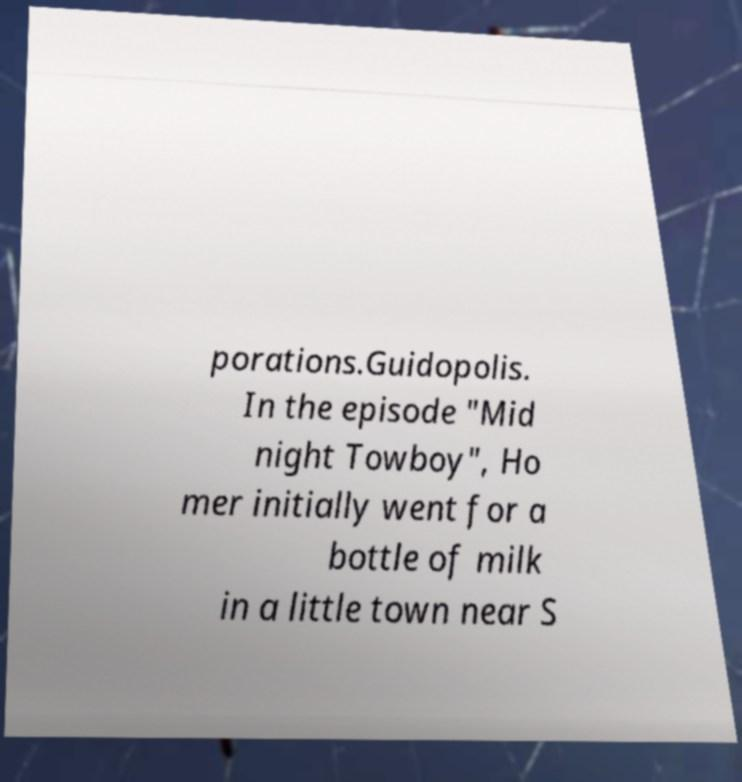Could you assist in decoding the text presented in this image and type it out clearly? porations.Guidopolis. In the episode "Mid night Towboy", Ho mer initially went for a bottle of milk in a little town near S 